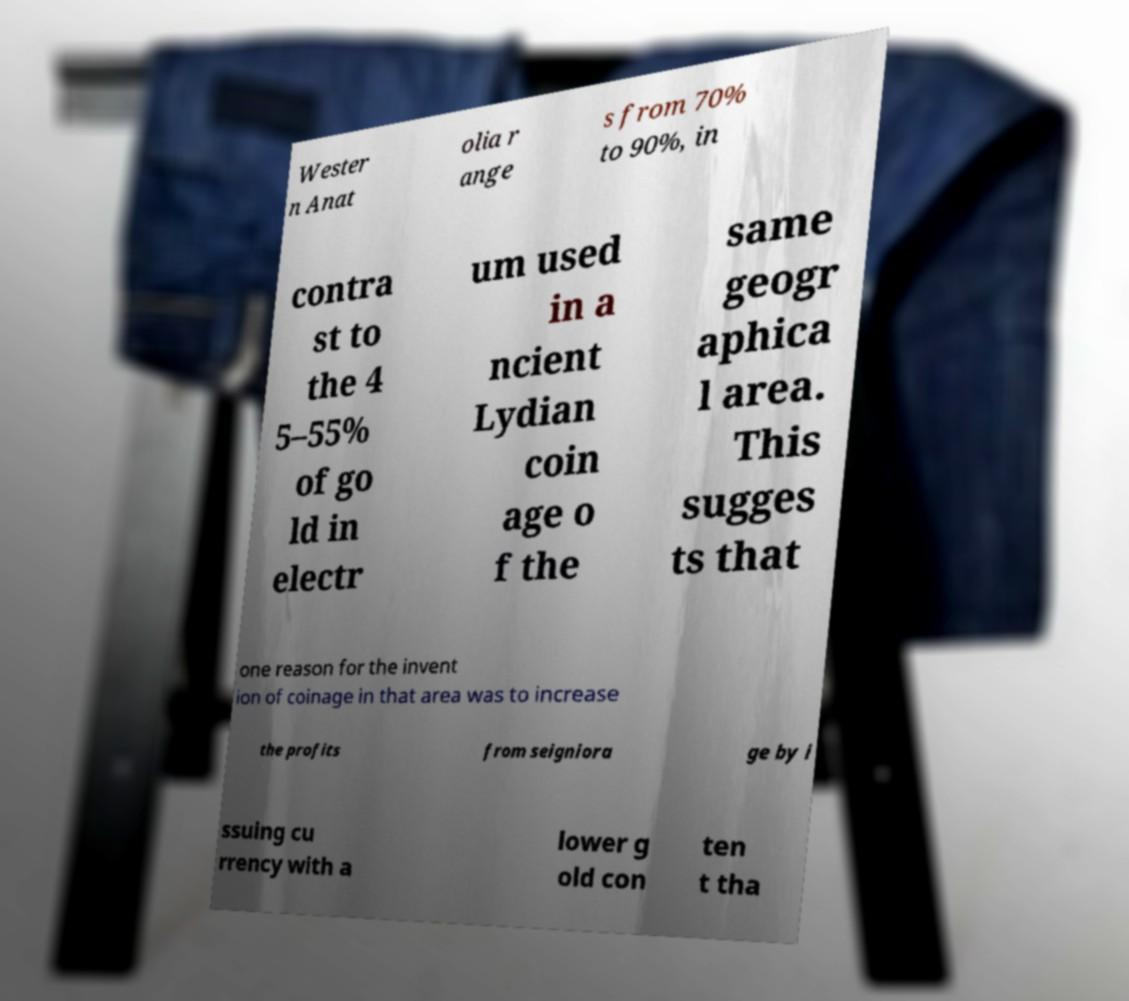I need the written content from this picture converted into text. Can you do that? Wester n Anat olia r ange s from 70% to 90%, in contra st to the 4 5–55% of go ld in electr um used in a ncient Lydian coin age o f the same geogr aphica l area. This sugges ts that one reason for the invent ion of coinage in that area was to increase the profits from seigniora ge by i ssuing cu rrency with a lower g old con ten t tha 